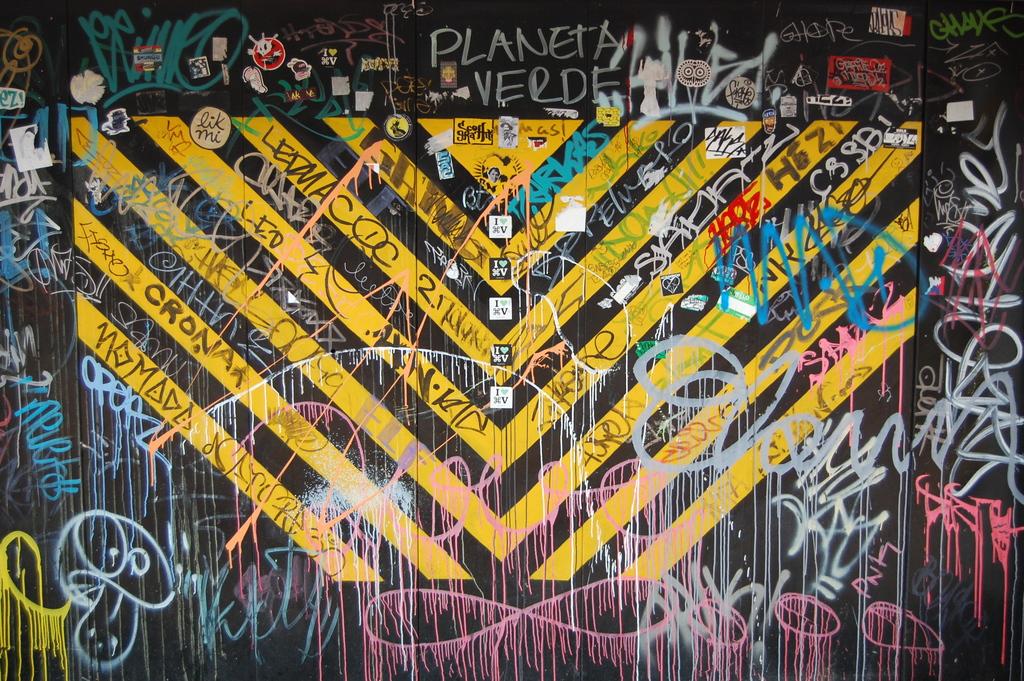What does some of this grafeti say?
Provide a short and direct response. Planeta verde. 